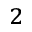<formula> <loc_0><loc_0><loc_500><loc_500>_ { 2 }</formula> 